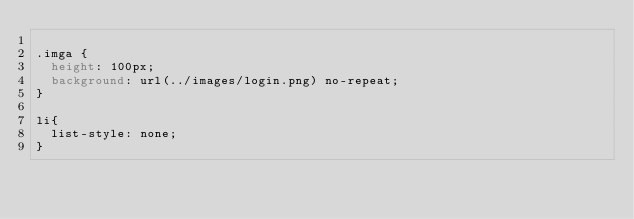<code> <loc_0><loc_0><loc_500><loc_500><_CSS_>
.imga {
	height: 100px;
	background: url(../images/login.png) no-repeat;
}

li{
  list-style: none;
}
</code> 